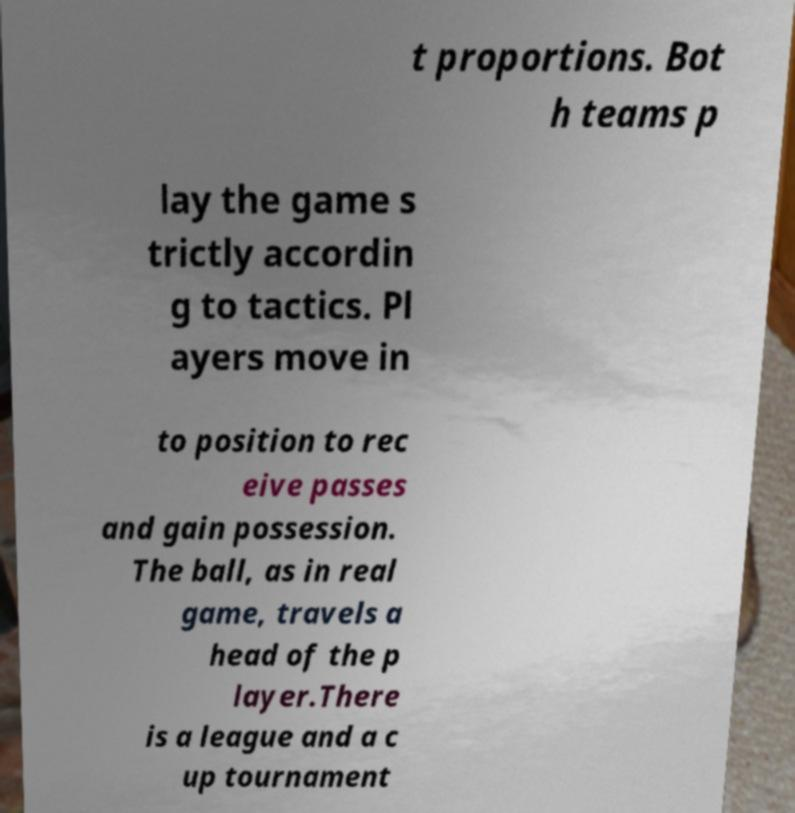Could you extract and type out the text from this image? t proportions. Bot h teams p lay the game s trictly accordin g to tactics. Pl ayers move in to position to rec eive passes and gain possession. The ball, as in real game, travels a head of the p layer.There is a league and a c up tournament 